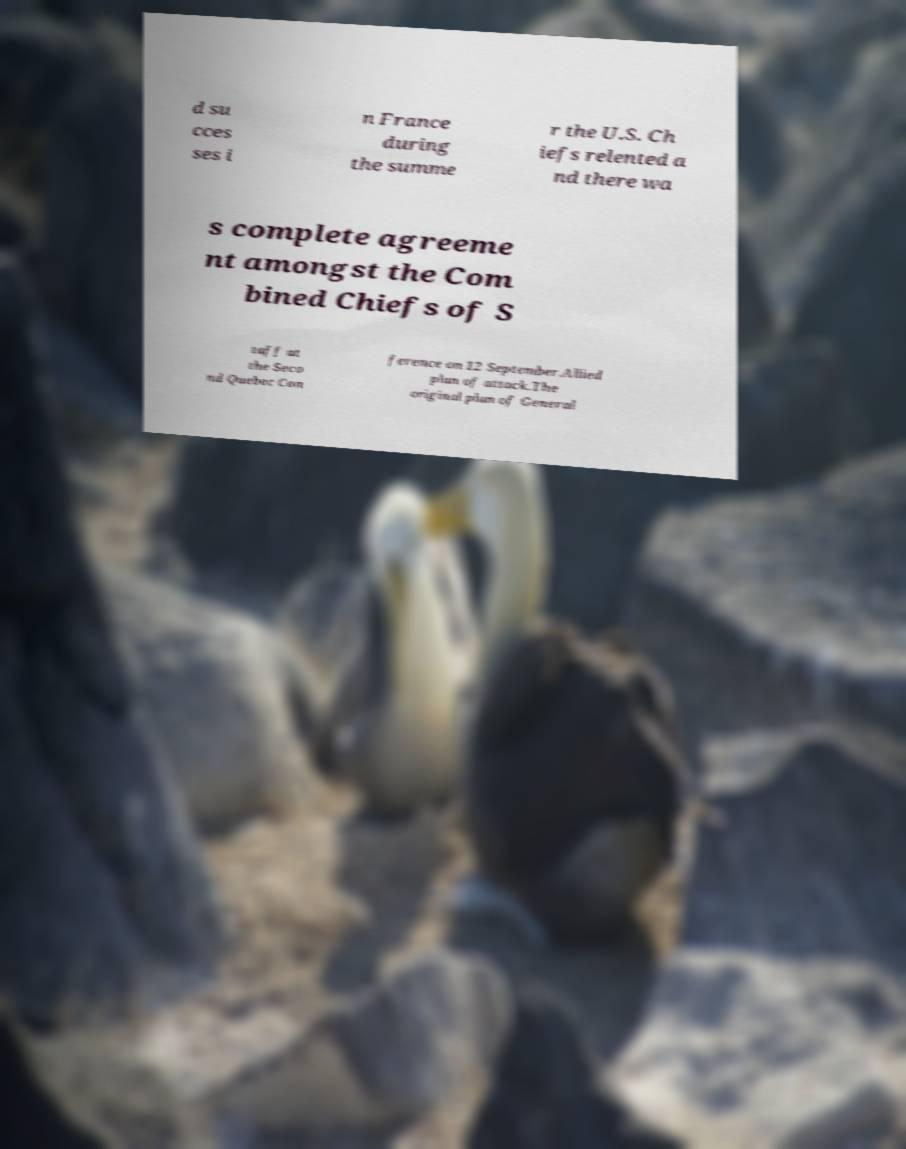Please read and relay the text visible in this image. What does it say? d su cces ses i n France during the summe r the U.S. Ch iefs relented a nd there wa s complete agreeme nt amongst the Com bined Chiefs of S taff at the Seco nd Quebec Con ference on 12 September.Allied plan of attack.The original plan of General 